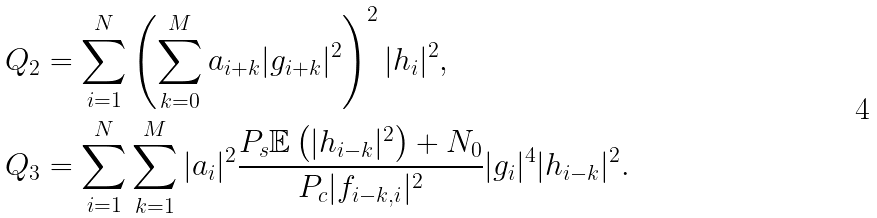Convert formula to latex. <formula><loc_0><loc_0><loc_500><loc_500>Q _ { 2 } & = \sum _ { i = 1 } ^ { N } \left ( \sum _ { k = 0 } ^ { M } a _ { i + k } | g _ { i + k } | ^ { 2 } \right ) ^ { 2 } | h _ { i } | ^ { 2 } , \\ Q _ { 3 } & = \sum _ { i = 1 } ^ { N } \sum _ { k = 1 } ^ { M } | a _ { i } | ^ { 2 } \frac { P _ { s } \mathbb { E } \left ( | h _ { i - k } | ^ { 2 } \right ) + N _ { 0 } } { P _ { c } | f _ { i - k , i } | ^ { 2 } } | g _ { i } | ^ { 4 } | h _ { i - k } | ^ { 2 } .</formula> 